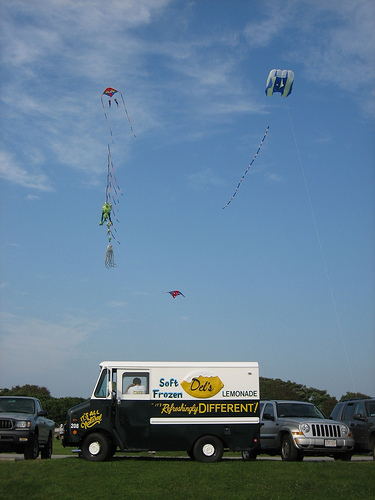Identify the text displayed in this image. Soft Frozen Del's LEMONADE DIFFERENT IT'S ALL 